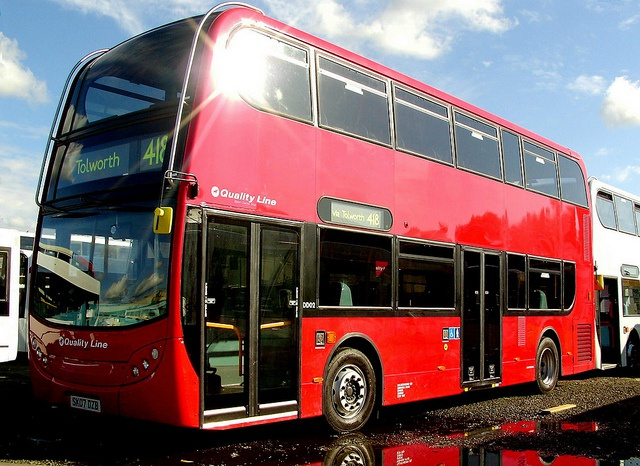Describe the objects in this image and their specific colors. I can see bus in lightblue, black, red, salmon, and white tones, bus in lightblue, white, black, and darkgray tones, and bus in lightblue, white, black, gray, and darkgray tones in this image. 